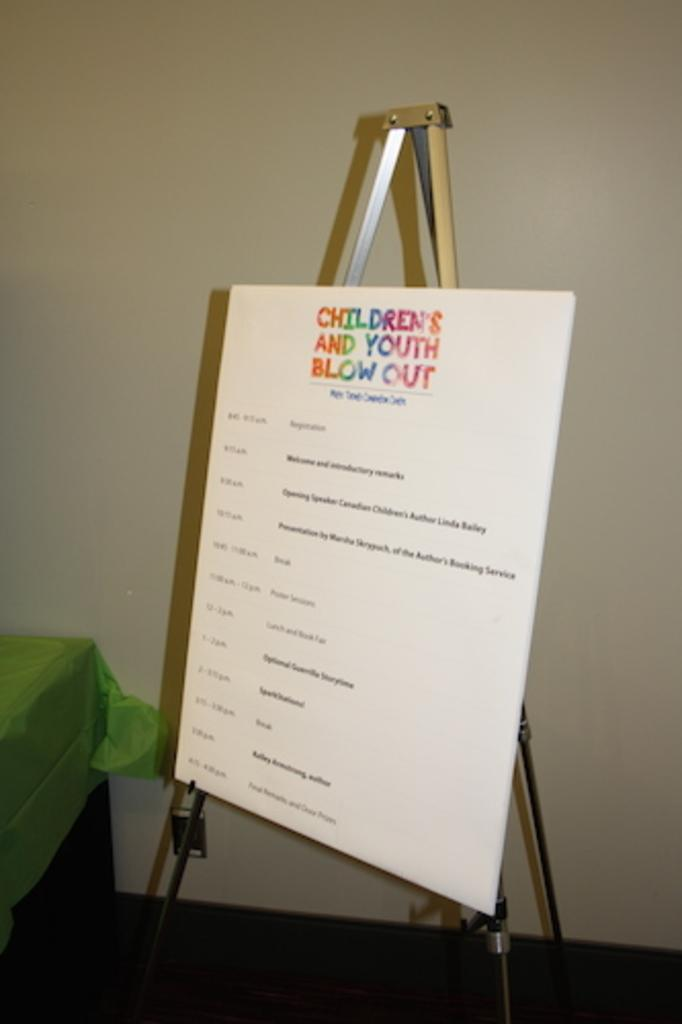<image>
Present a compact description of the photo's key features. A white board on an easel titled Children's and Youth Blow Outs. 